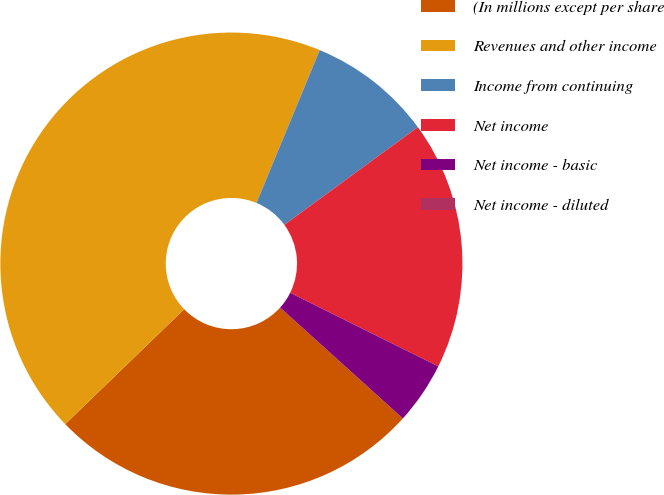Convert chart to OTSL. <chart><loc_0><loc_0><loc_500><loc_500><pie_chart><fcel>(In millions except per share<fcel>Revenues and other income<fcel>Income from continuing<fcel>Net income<fcel>Net income - basic<fcel>Net income - diluted<nl><fcel>26.08%<fcel>43.47%<fcel>8.7%<fcel>17.39%<fcel>4.35%<fcel>0.0%<nl></chart> 